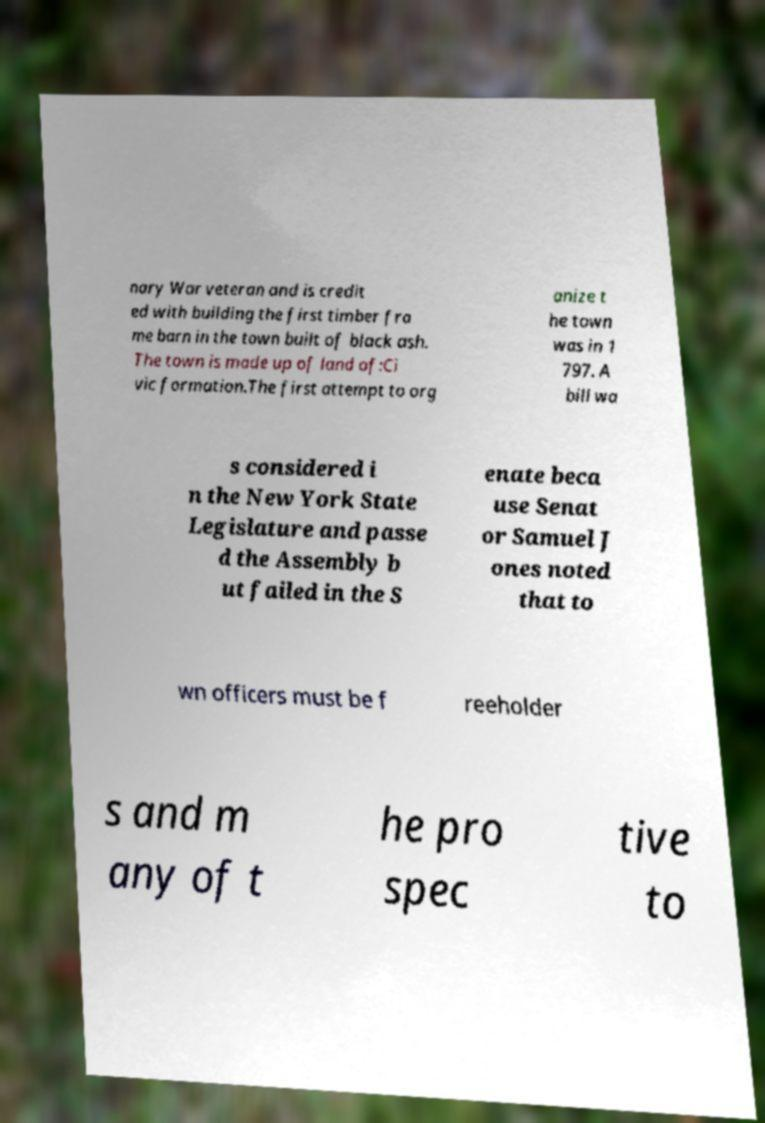There's text embedded in this image that I need extracted. Can you transcribe it verbatim? nary War veteran and is credit ed with building the first timber fra me barn in the town built of black ash. The town is made up of land of:Ci vic formation.The first attempt to org anize t he town was in 1 797. A bill wa s considered i n the New York State Legislature and passe d the Assembly b ut failed in the S enate beca use Senat or Samuel J ones noted that to wn officers must be f reeholder s and m any of t he pro spec tive to 